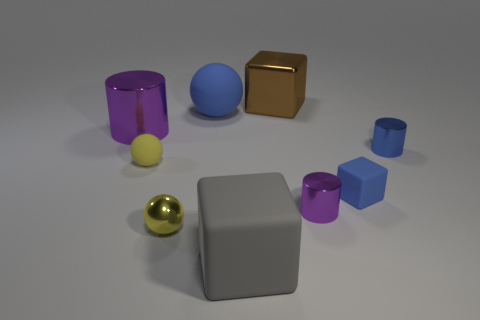Is there a large red metal thing of the same shape as the large purple object?
Your response must be concise. No. There is a thing that is behind the large metallic cylinder and right of the gray rubber thing; what is its shape?
Make the answer very short. Cube. Do the big brown object and the purple cylinder that is to the right of the large purple shiny object have the same material?
Keep it short and to the point. Yes. Are there any tiny metallic cylinders in front of the gray object?
Keep it short and to the point. No. What number of objects are gray matte objects or large things behind the big purple metallic thing?
Give a very brief answer. 3. What is the color of the matte ball that is behind the small metal cylinder that is behind the small matte cube?
Your answer should be very brief. Blue. What number of other things are there of the same material as the brown object
Offer a very short reply. 4. How many shiny things are either brown cubes or purple things?
Your answer should be compact. 3. What is the color of the other small shiny thing that is the same shape as the tiny purple object?
Provide a short and direct response. Blue. How many objects are either small rubber spheres or yellow metallic spheres?
Offer a very short reply. 2. 